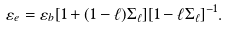<formula> <loc_0><loc_0><loc_500><loc_500>\varepsilon _ { e } = \varepsilon _ { b } [ 1 + ( 1 - \ell ) \Sigma _ { \ell } ] [ 1 - \ell \Sigma _ { \ell } ] ^ { - 1 } .</formula> 